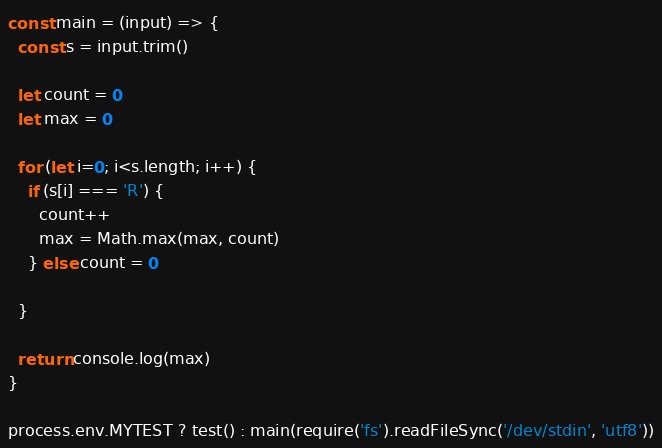Convert code to text. <code><loc_0><loc_0><loc_500><loc_500><_JavaScript_>const main = (input) => {
  const s = input.trim()

  let count = 0
  let max = 0

  for (let i=0; i<s.length; i++) {
    if (s[i] === 'R') {
      count++
      max = Math.max(max, count)
    } else count = 0

  }

  return console.log(max)
}

process.env.MYTEST ? test() : main(require('fs').readFileSync('/dev/stdin', 'utf8'))</code> 